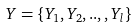<formula> <loc_0><loc_0><loc_500><loc_500>Y = \{ Y _ { 1 } , Y _ { 2 } , . . , , Y _ { l } \}</formula> 